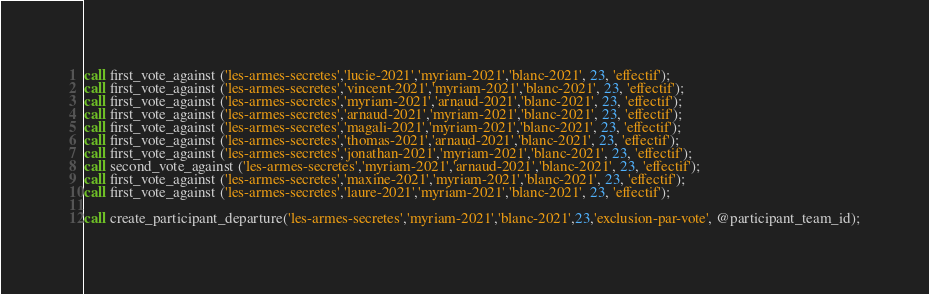<code> <loc_0><loc_0><loc_500><loc_500><_SQL_>call first_vote_against ('les-armes-secretes','lucie-2021','myriam-2021','blanc-2021', 23, 'effectif');
call first_vote_against ('les-armes-secretes','vincent-2021','myriam-2021','blanc-2021', 23, 'effectif');
call first_vote_against ('les-armes-secretes','myriam-2021','arnaud-2021','blanc-2021', 23, 'effectif');
call first_vote_against ('les-armes-secretes','arnaud-2021','myriam-2021','blanc-2021', 23, 'effectif');
call first_vote_against ('les-armes-secretes','magali-2021','myriam-2021','blanc-2021', 23, 'effectif');
call first_vote_against ('les-armes-secretes','thomas-2021','arnaud-2021','blanc-2021', 23, 'effectif');
call first_vote_against ('les-armes-secretes','jonathan-2021','myriam-2021','blanc-2021', 23, 'effectif');
call second_vote_against ('les-armes-secretes','myriam-2021','arnaud-2021','blanc-2021', 23, 'effectif');
call first_vote_against ('les-armes-secretes','maxine-2021','myriam-2021','blanc-2021', 23, 'effectif');
call first_vote_against ('les-armes-secretes','laure-2021','myriam-2021','blanc-2021', 23, 'effectif');

call create_participant_departure('les-armes-secretes','myriam-2021','blanc-2021',23,'exclusion-par-vote', @participant_team_id);

</code> 